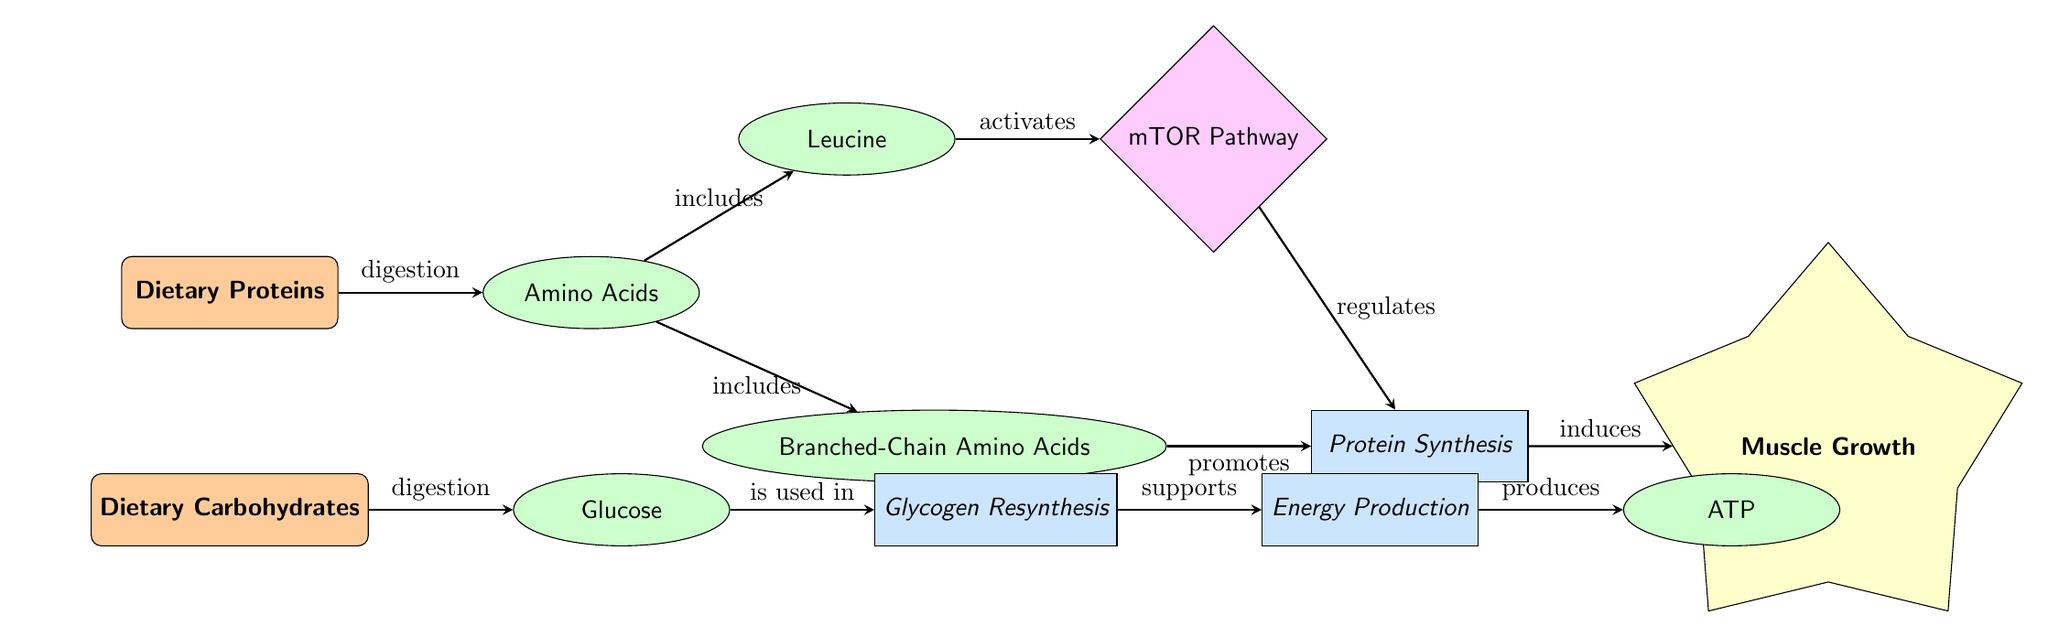What is the first nutrient shown in the diagram? The first nutrient node on the diagram is labeled "Dietary Proteins." It is located at the top of the diagram, representing the initial input affecting muscle recovery.
Answer: Dietary Proteins What process is induced by Protein Synthesis? Protein Synthesis is shown to lead to an outcome labeled "Muscle Growth," which is directly indicated as the result of the process in the diagram.
Answer: Muscle Growth Which compound activates the mTOR Pathway? The compound "Leucine" is connected to the mTOR Pathway via an "activates" label, indicating Leucine's key role in stimulating this pathway for muscle recovery.
Answer: Leucine How many dietary nutrients are indicated in the diagram? There are two dietary nutrients depicted in the diagram, "Dietary Proteins" and "Dietary Carbohydrates." Both are shown as initial inputs related to muscle recovery.
Answer: 2 What outcome is produced as a result of energy production? The diagram indicates that the process "Energy Production" produces the compound "ATP," which is necessary for various cellular functions, including muscle contractions.
Answer: ATP Which nutrient is converted into Glucose? The dietary nutrient "Dietary Carbohydrates" is digested to produce the compound "Glucose," which is clearly indicated in the flow of processes in the diagram.
Answer: Dietary Carbohydrates What do Branched-Chain Amino Acids promote? Branched-Chain Amino Acids are shown to "promote" the process of Protein Synthesis, which is essential for muscle repair and recovery in the diagram.
Answer: Protein Synthesis What is the relationship between Glycogen Resynthesis and Energy Production? Glycogen Resynthesis "supports" the Energy Production process as seen in the diagram. This indicates a dependency where glycogen plays a role in creating energy during recovery.
Answer: supports 